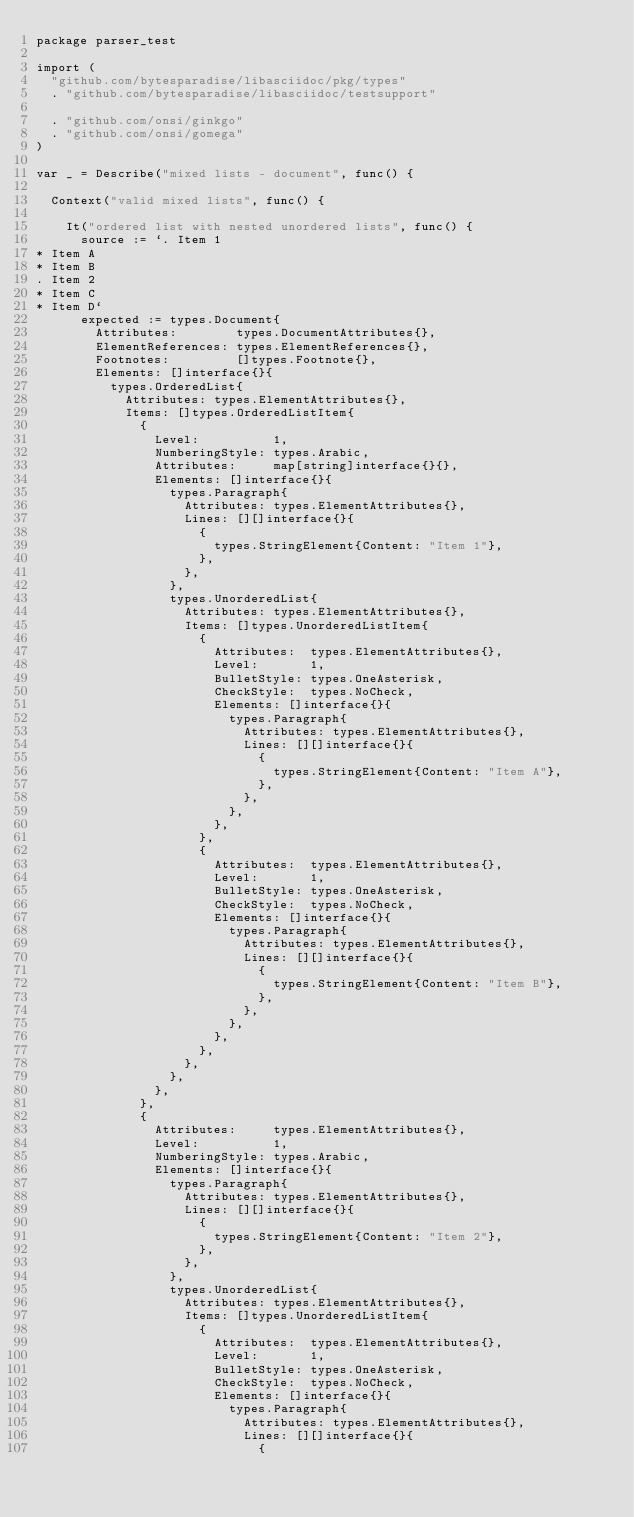<code> <loc_0><loc_0><loc_500><loc_500><_Go_>package parser_test

import (
	"github.com/bytesparadise/libasciidoc/pkg/types"
	. "github.com/bytesparadise/libasciidoc/testsupport"

	. "github.com/onsi/ginkgo"
	. "github.com/onsi/gomega"
)

var _ = Describe("mixed lists - document", func() {

	Context("valid mixed lists", func() {

		It("ordered list with nested unordered lists", func() {
			source := `. Item 1
* Item A
* Item B
. Item 2
* Item C
* Item D`
			expected := types.Document{
				Attributes:        types.DocumentAttributes{},
				ElementReferences: types.ElementReferences{},
				Footnotes:         []types.Footnote{},
				Elements: []interface{}{
					types.OrderedList{
						Attributes: types.ElementAttributes{},
						Items: []types.OrderedListItem{
							{
								Level:          1,
								NumberingStyle: types.Arabic,
								Attributes:     map[string]interface{}{},
								Elements: []interface{}{
									types.Paragraph{
										Attributes: types.ElementAttributes{},
										Lines: [][]interface{}{
											{
												types.StringElement{Content: "Item 1"},
											},
										},
									},
									types.UnorderedList{
										Attributes: types.ElementAttributes{},
										Items: []types.UnorderedListItem{
											{
												Attributes:  types.ElementAttributes{},
												Level:       1,
												BulletStyle: types.OneAsterisk,
												CheckStyle:  types.NoCheck,
												Elements: []interface{}{
													types.Paragraph{
														Attributes: types.ElementAttributes{},
														Lines: [][]interface{}{
															{
																types.StringElement{Content: "Item A"},
															},
														},
													},
												},
											},
											{
												Attributes:  types.ElementAttributes{},
												Level:       1,
												BulletStyle: types.OneAsterisk,
												CheckStyle:  types.NoCheck,
												Elements: []interface{}{
													types.Paragraph{
														Attributes: types.ElementAttributes{},
														Lines: [][]interface{}{
															{
																types.StringElement{Content: "Item B"},
															},
														},
													},
												},
											},
										},
									},
								},
							},
							{
								Attributes:     types.ElementAttributes{},
								Level:          1,
								NumberingStyle: types.Arabic,
								Elements: []interface{}{
									types.Paragraph{
										Attributes: types.ElementAttributes{},
										Lines: [][]interface{}{
											{
												types.StringElement{Content: "Item 2"},
											},
										},
									},
									types.UnorderedList{
										Attributes: types.ElementAttributes{},
										Items: []types.UnorderedListItem{
											{
												Attributes:  types.ElementAttributes{},
												Level:       1,
												BulletStyle: types.OneAsterisk,
												CheckStyle:  types.NoCheck,
												Elements: []interface{}{
													types.Paragraph{
														Attributes: types.ElementAttributes{},
														Lines: [][]interface{}{
															{</code> 